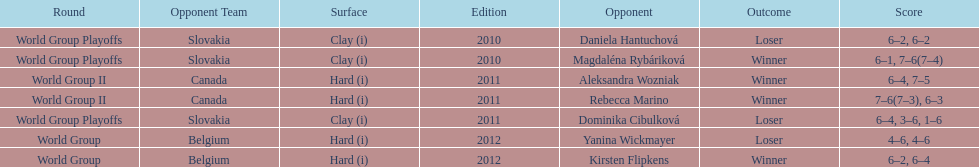What was the next game listed after the world group ii rounds? World Group Playoffs. 